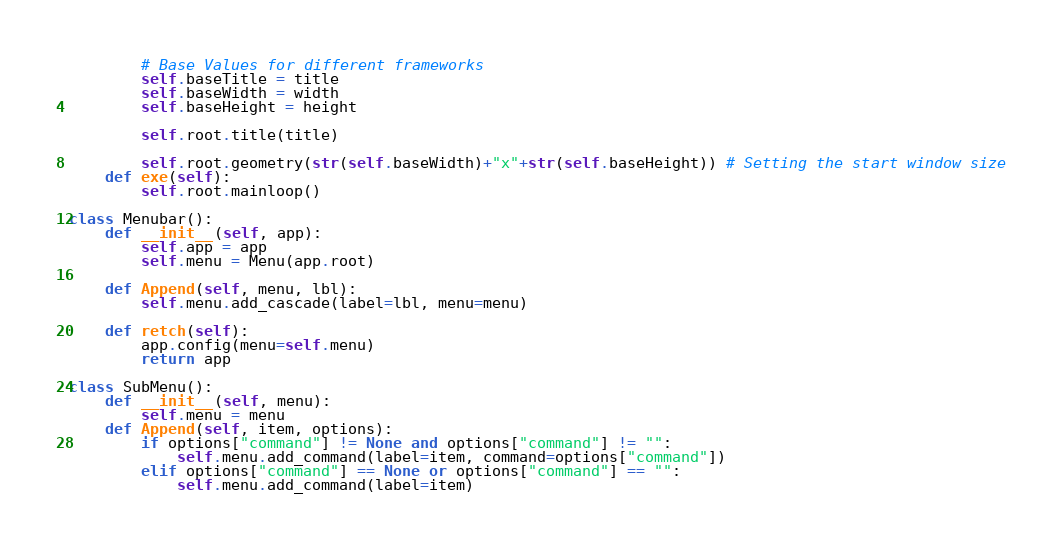<code> <loc_0><loc_0><loc_500><loc_500><_Python_>
        # Base Values for different frameworks
        self.baseTitle = title
        self.baseWidth = width
        self.baseHeight = height

        self.root.title(title)

        self.root.geometry(str(self.baseWidth)+"x"+str(self.baseHeight)) # Setting the start window size
    def exe(self):
        self.root.mainloop()

class Menubar():
    def __init__(self, app):
        self.app = app
        self.menu = Menu(app.root)

    def Append(self, menu, lbl):
        self.menu.add_cascade(label=lbl, menu=menu)

    def retch(self):
        app.config(menu=self.menu)
        return app

class SubMenu():
    def __init__(self, menu):
        self.menu = menu
    def Append(self, item, options):
        if options["command"] != None and options["command"] != "":
            self.menu.add_command(label=item, command=options["command"])
        elif options["command"] == None or options["command"] == "":
            self.menu.add_command(label=item)
</code> 